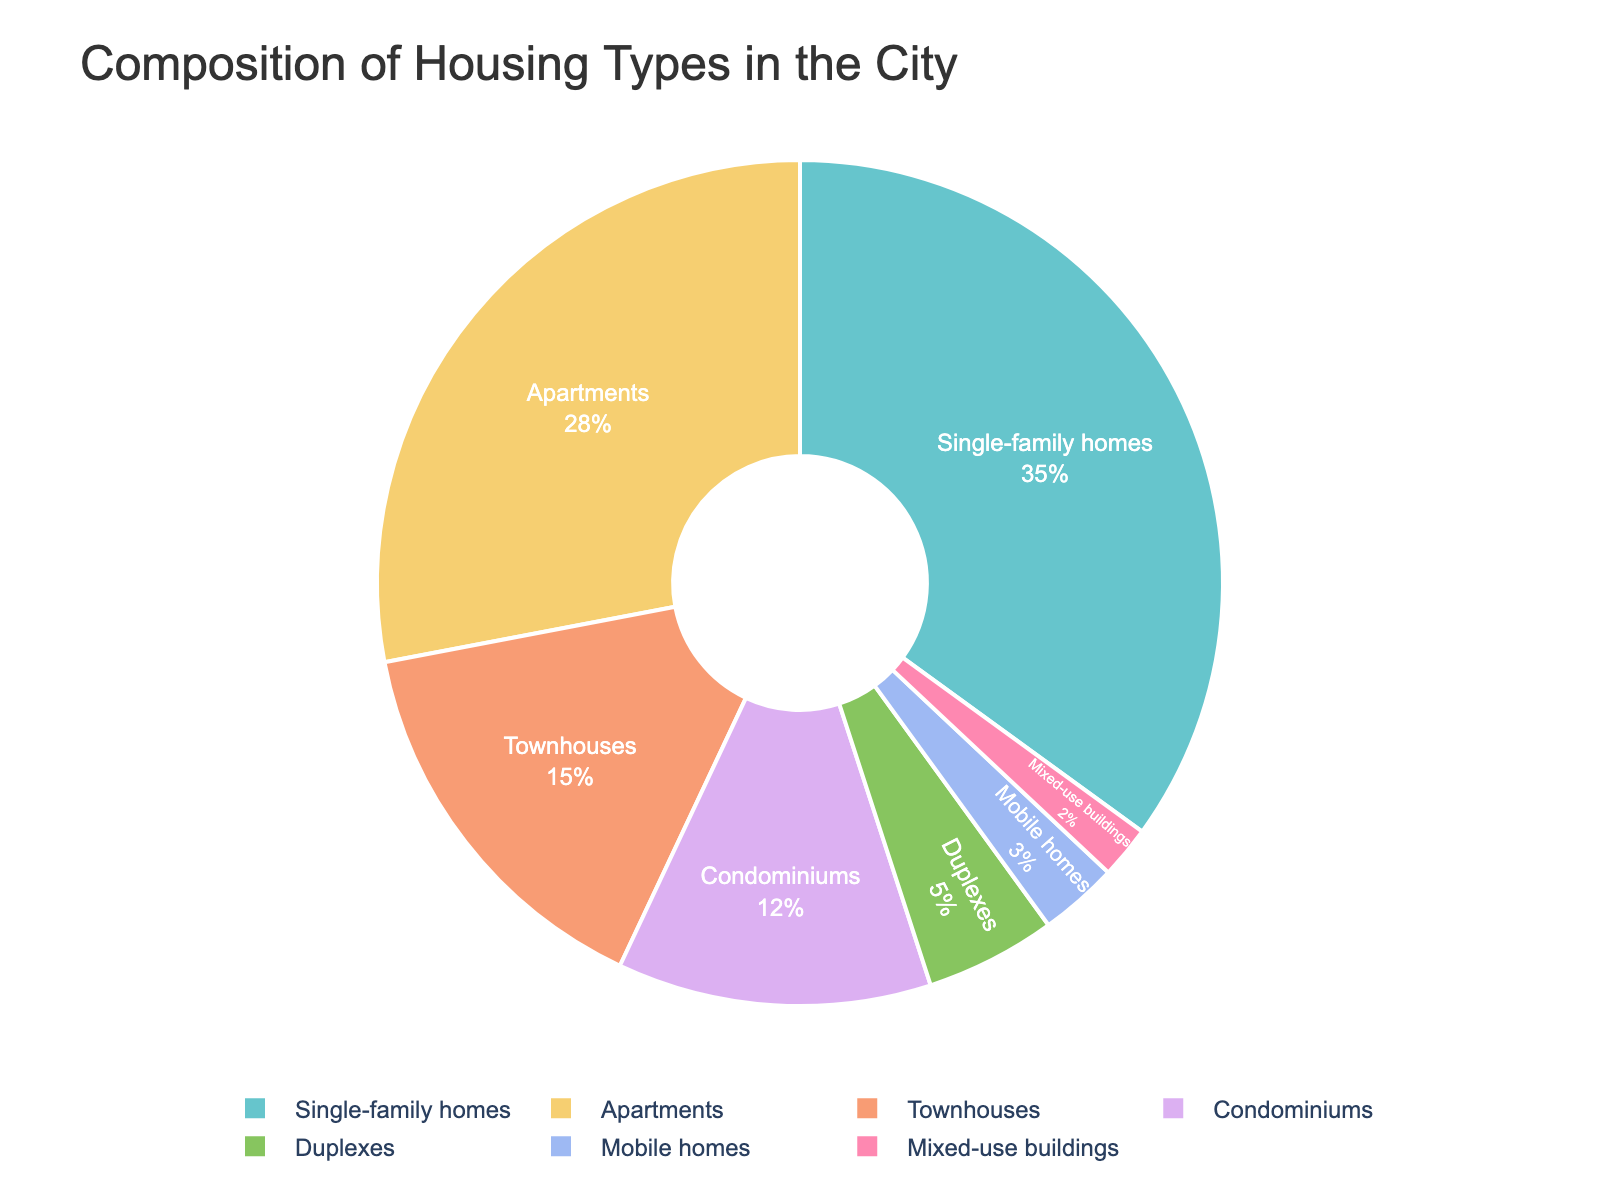What is the largest housing type in the city? Look at the pie chart and identify the housing type with the largest percentage. Single-family homes have the largest portion, which is 35%.
Answer: Single-family homes What is the total percentage of Apartments and Townhouses combined? Add the percentages of Apartments (28%) and Townhouses (15%). 28 + 15 = 43
Answer: 43 Which housing type has the smallest share? Identify the housing type with the smallest percentage in the pie chart. Mixed-use buildings have the smallest share at 2%.
Answer: Mixed-use buildings How much larger is the percentage of Single-family homes compared to Duplexes? Subtract the percentage of Duplexes (5%) from Single-family homes (35%). 35 - 5 = 30
Answer: 30 What percentage of the city's housing is made up of Condominiums and Mobile homes combined? Add the percentages of Condominiums (12%) and Mobile homes (3%). 12 + 3 = 15
Answer: 15 Which two housing types together have a larger share than Apartments alone? Identify two housing types whose combined percentages exceed that of Apartments (28%). Single-family homes (35%) and Mobile homes (3%) combined make 38%, which is larger than 28%.
Answer: Single-family homes and Mobile homes What is the difference in the percentage of Townhouses and Mobile homes? Subtract the percentage of Mobile homes (3%) from Townhouses (15%). 15 - 3 = 12
Answer: 12 How much smaller is the percentage of Mixed-use buildings compared to Condominiums? Subtract the percentage of Mixed-use buildings (2%) from Condominiums (12%). 12 - 2 = 10
Answer: 10 Which housing type occupies approximately one-fourth of the chart? Identify the housing type whose percentage is closest to one-fourth (25%). Apartments at 28% fits this criterion well.
Answer: Apartments 